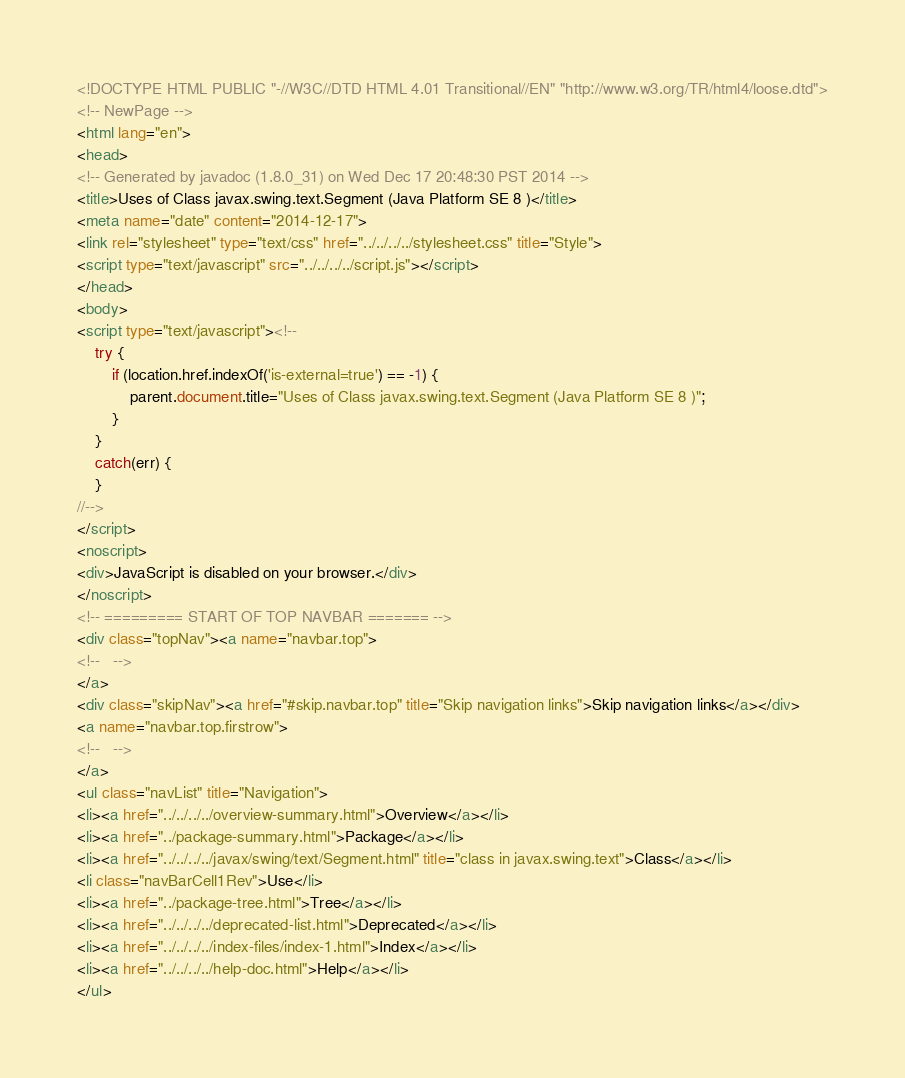Convert code to text. <code><loc_0><loc_0><loc_500><loc_500><_HTML_><!DOCTYPE HTML PUBLIC "-//W3C//DTD HTML 4.01 Transitional//EN" "http://www.w3.org/TR/html4/loose.dtd">
<!-- NewPage -->
<html lang="en">
<head>
<!-- Generated by javadoc (1.8.0_31) on Wed Dec 17 20:48:30 PST 2014 -->
<title>Uses of Class javax.swing.text.Segment (Java Platform SE 8 )</title>
<meta name="date" content="2014-12-17">
<link rel="stylesheet" type="text/css" href="../../../../stylesheet.css" title="Style">
<script type="text/javascript" src="../../../../script.js"></script>
</head>
<body>
<script type="text/javascript"><!--
    try {
        if (location.href.indexOf('is-external=true') == -1) {
            parent.document.title="Uses of Class javax.swing.text.Segment (Java Platform SE 8 )";
        }
    }
    catch(err) {
    }
//-->
</script>
<noscript>
<div>JavaScript is disabled on your browser.</div>
</noscript>
<!-- ========= START OF TOP NAVBAR ======= -->
<div class="topNav"><a name="navbar.top">
<!--   -->
</a>
<div class="skipNav"><a href="#skip.navbar.top" title="Skip navigation links">Skip navigation links</a></div>
<a name="navbar.top.firstrow">
<!--   -->
</a>
<ul class="navList" title="Navigation">
<li><a href="../../../../overview-summary.html">Overview</a></li>
<li><a href="../package-summary.html">Package</a></li>
<li><a href="../../../../javax/swing/text/Segment.html" title="class in javax.swing.text">Class</a></li>
<li class="navBarCell1Rev">Use</li>
<li><a href="../package-tree.html">Tree</a></li>
<li><a href="../../../../deprecated-list.html">Deprecated</a></li>
<li><a href="../../../../index-files/index-1.html">Index</a></li>
<li><a href="../../../../help-doc.html">Help</a></li>
</ul></code> 